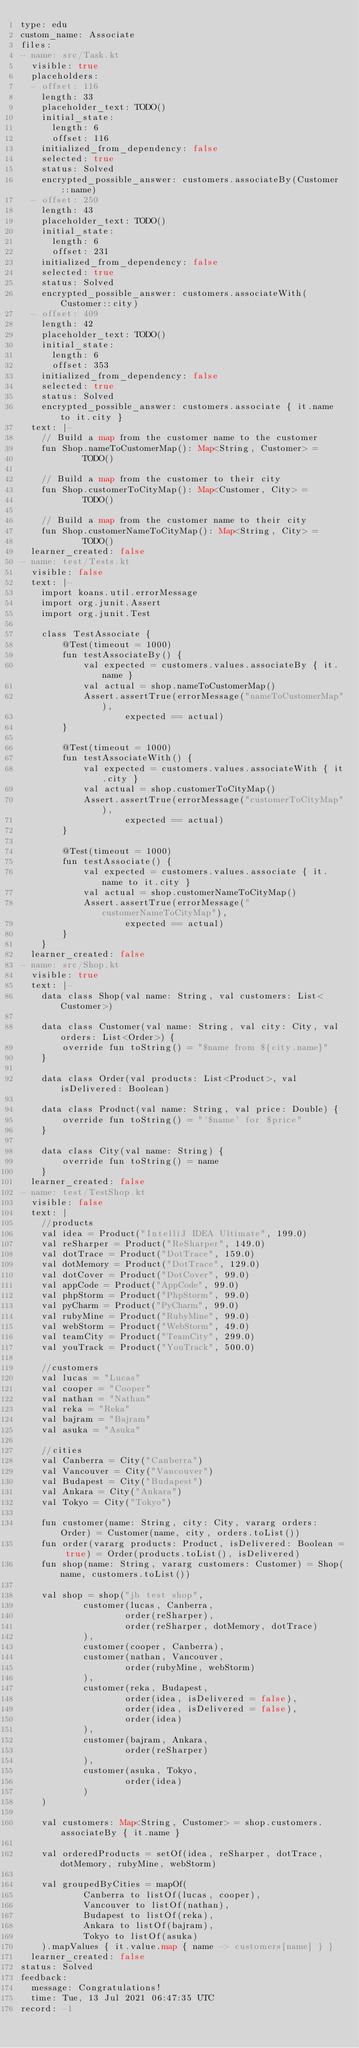Convert code to text. <code><loc_0><loc_0><loc_500><loc_500><_YAML_>type: edu
custom_name: Associate
files:
- name: src/Task.kt
  visible: true
  placeholders:
  - offset: 116
    length: 33
    placeholder_text: TODO()
    initial_state:
      length: 6
      offset: 116
    initialized_from_dependency: false
    selected: true
    status: Solved
    encrypted_possible_answer: customers.associateBy(Customer::name)
  - offset: 250
    length: 43
    placeholder_text: TODO()
    initial_state:
      length: 6
      offset: 231
    initialized_from_dependency: false
    selected: true
    status: Solved
    encrypted_possible_answer: customers.associateWith(Customer::city)
  - offset: 409
    length: 42
    placeholder_text: TODO()
    initial_state:
      length: 6
      offset: 353
    initialized_from_dependency: false
    selected: true
    status: Solved
    encrypted_possible_answer: customers.associate { it.name to it.city }
  text: |-
    // Build a map from the customer name to the customer
    fun Shop.nameToCustomerMap(): Map<String, Customer> =
            TODO()

    // Build a map from the customer to their city
    fun Shop.customerToCityMap(): Map<Customer, City> =
            TODO()

    // Build a map from the customer name to their city
    fun Shop.customerNameToCityMap(): Map<String, City> =
            TODO()
  learner_created: false
- name: test/Tests.kt
  visible: false
  text: |-
    import koans.util.errorMessage
    import org.junit.Assert
    import org.junit.Test

    class TestAssociate {
        @Test(timeout = 1000)
        fun testAssociateBy() {
            val expected = customers.values.associateBy { it.name }
            val actual = shop.nameToCustomerMap()
            Assert.assertTrue(errorMessage("nameToCustomerMap"),
                    expected == actual)
        }

        @Test(timeout = 1000)
        fun testAssociateWith() {
            val expected = customers.values.associateWith { it.city }
            val actual = shop.customerToCityMap()
            Assert.assertTrue(errorMessage("customerToCityMap"),
                    expected == actual)
        }

        @Test(timeout = 1000)
        fun testAssociate() {
            val expected = customers.values.associate { it.name to it.city }
            val actual = shop.customerNameToCityMap()
            Assert.assertTrue(errorMessage("customerNameToCityMap"),
                    expected == actual)
        }
    }
  learner_created: false
- name: src/Shop.kt
  visible: true
  text: |-
    data class Shop(val name: String, val customers: List<Customer>)

    data class Customer(val name: String, val city: City, val orders: List<Order>) {
        override fun toString() = "$name from ${city.name}"
    }

    data class Order(val products: List<Product>, val isDelivered: Boolean)

    data class Product(val name: String, val price: Double) {
        override fun toString() = "'$name' for $price"
    }

    data class City(val name: String) {
        override fun toString() = name
    }
  learner_created: false
- name: test/TestShop.kt
  visible: false
  text: |
    //products
    val idea = Product("IntelliJ IDEA Ultimate", 199.0)
    val reSharper = Product("ReSharper", 149.0)
    val dotTrace = Product("DotTrace", 159.0)
    val dotMemory = Product("DotTrace", 129.0)
    val dotCover = Product("DotCover", 99.0)
    val appCode = Product("AppCode", 99.0)
    val phpStorm = Product("PhpStorm", 99.0)
    val pyCharm = Product("PyCharm", 99.0)
    val rubyMine = Product("RubyMine", 99.0)
    val webStorm = Product("WebStorm", 49.0)
    val teamCity = Product("TeamCity", 299.0)
    val youTrack = Product("YouTrack", 500.0)

    //customers
    val lucas = "Lucas"
    val cooper = "Cooper"
    val nathan = "Nathan"
    val reka = "Reka"
    val bajram = "Bajram"
    val asuka = "Asuka"

    //cities
    val Canberra = City("Canberra")
    val Vancouver = City("Vancouver")
    val Budapest = City("Budapest")
    val Ankara = City("Ankara")
    val Tokyo = City("Tokyo")

    fun customer(name: String, city: City, vararg orders: Order) = Customer(name, city, orders.toList())
    fun order(vararg products: Product, isDelivered: Boolean = true) = Order(products.toList(), isDelivered)
    fun shop(name: String, vararg customers: Customer) = Shop(name, customers.toList())

    val shop = shop("jb test shop",
            customer(lucas, Canberra,
                    order(reSharper),
                    order(reSharper, dotMemory, dotTrace)
            ),
            customer(cooper, Canberra),
            customer(nathan, Vancouver,
                    order(rubyMine, webStorm)
            ),
            customer(reka, Budapest,
                    order(idea, isDelivered = false),
                    order(idea, isDelivered = false),
                    order(idea)
            ),
            customer(bajram, Ankara,
                    order(reSharper)
            ),
            customer(asuka, Tokyo,
                    order(idea)
            )
    )

    val customers: Map<String, Customer> = shop.customers.associateBy { it.name }

    val orderedProducts = setOf(idea, reSharper, dotTrace, dotMemory, rubyMine, webStorm)

    val groupedByCities = mapOf(
            Canberra to listOf(lucas, cooper),
            Vancouver to listOf(nathan),
            Budapest to listOf(reka),
            Ankara to listOf(bajram),
            Tokyo to listOf(asuka)
    ).mapValues { it.value.map { name -> customers[name] } }
  learner_created: false
status: Solved
feedback:
  message: Congratulations!
  time: Tue, 13 Jul 2021 06:47:35 UTC
record: -1
</code> 